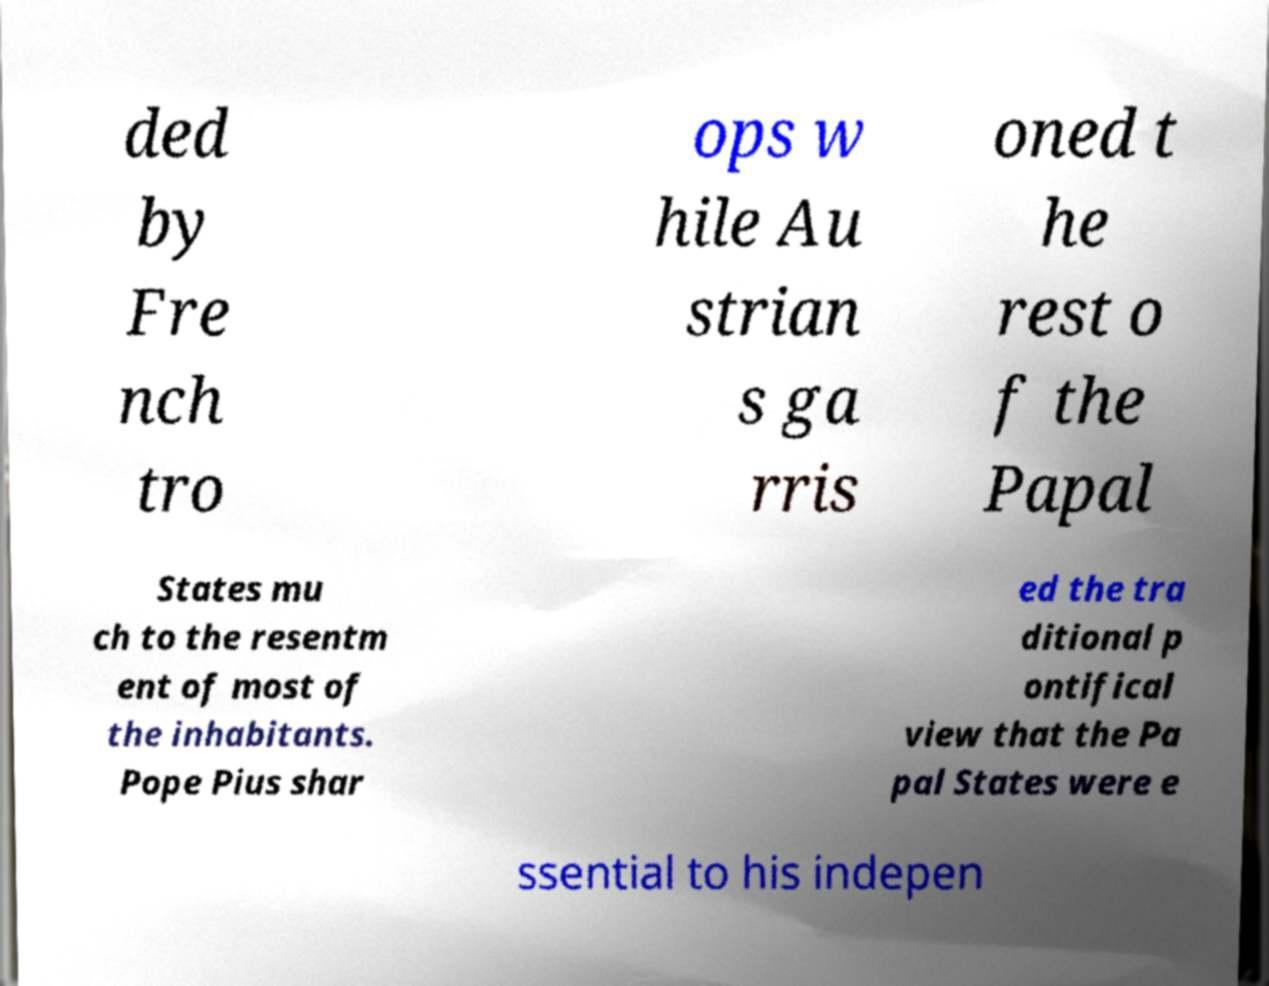What messages or text are displayed in this image? I need them in a readable, typed format. ded by Fre nch tro ops w hile Au strian s ga rris oned t he rest o f the Papal States mu ch to the resentm ent of most of the inhabitants. Pope Pius shar ed the tra ditional p ontifical view that the Pa pal States were e ssential to his indepen 